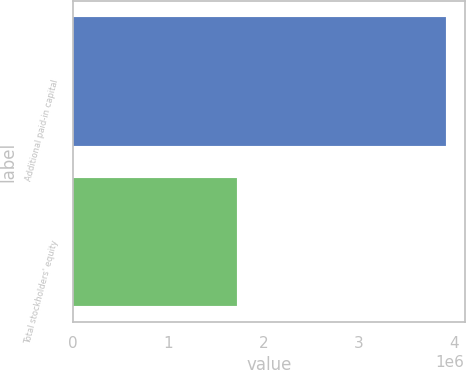Convert chart. <chart><loc_0><loc_0><loc_500><loc_500><bar_chart><fcel>Additional paid-in capital<fcel>Total stockholders' equity<nl><fcel>3.91088e+06<fcel>1.71827e+06<nl></chart> 